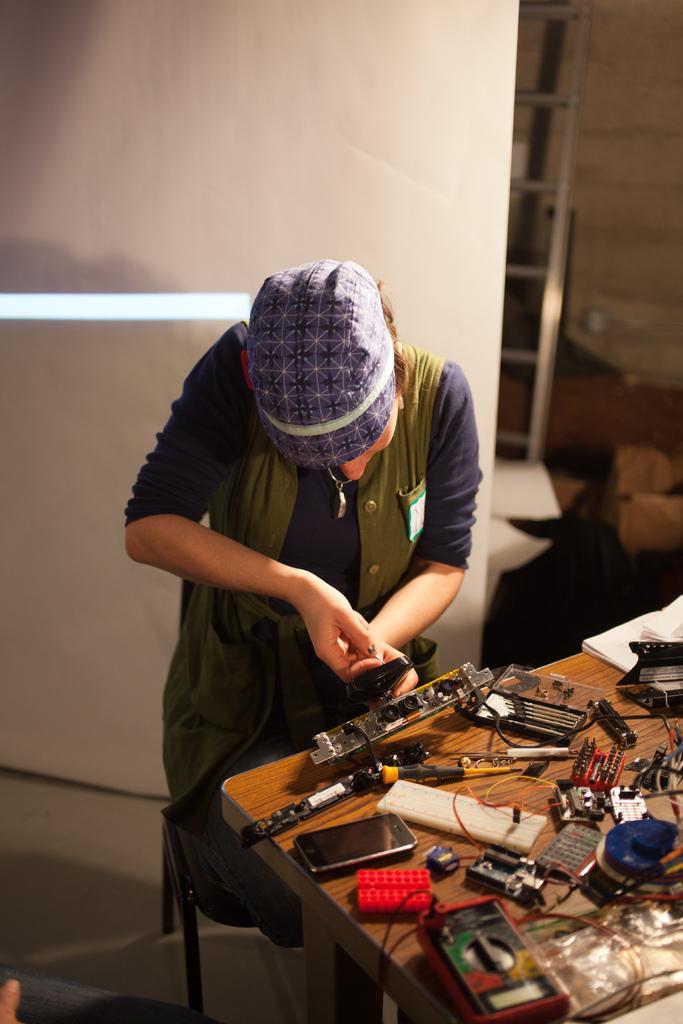Can you describe this image briefly? On the right side of the image there is a table with mobile, wires, tools and other items. Behind the building there is a person standing and there is a cap on the head. Behind the person there is a wall and also there is a ladder. 